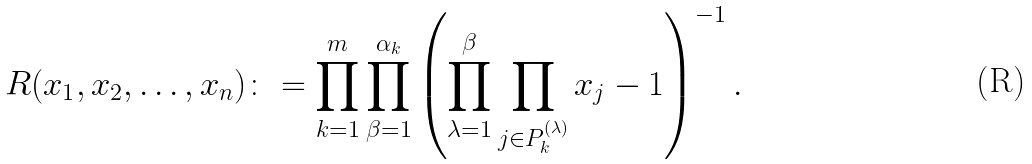Convert formula to latex. <formula><loc_0><loc_0><loc_500><loc_500>R ( x _ { 1 } , x _ { 2 } , \dots , x _ { n } ) \colon = \prod _ { k = 1 } ^ { m } \prod _ { \beta = 1 } ^ { \alpha _ { k } } \left ( \prod _ { \lambda = 1 } ^ { \beta } \prod _ { j \in P _ { k } ^ { ( \lambda ) } } x _ { j } - 1 \right ) ^ { - 1 } .</formula> 